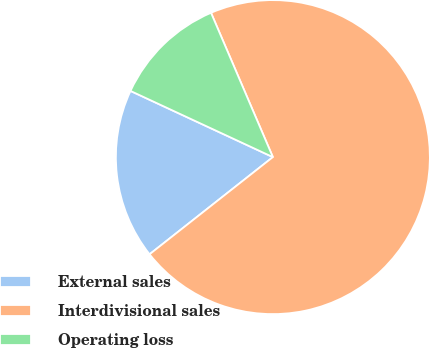Convert chart. <chart><loc_0><loc_0><loc_500><loc_500><pie_chart><fcel>External sales<fcel>Interdivisional sales<fcel>Operating loss<nl><fcel>17.55%<fcel>70.83%<fcel>11.63%<nl></chart> 